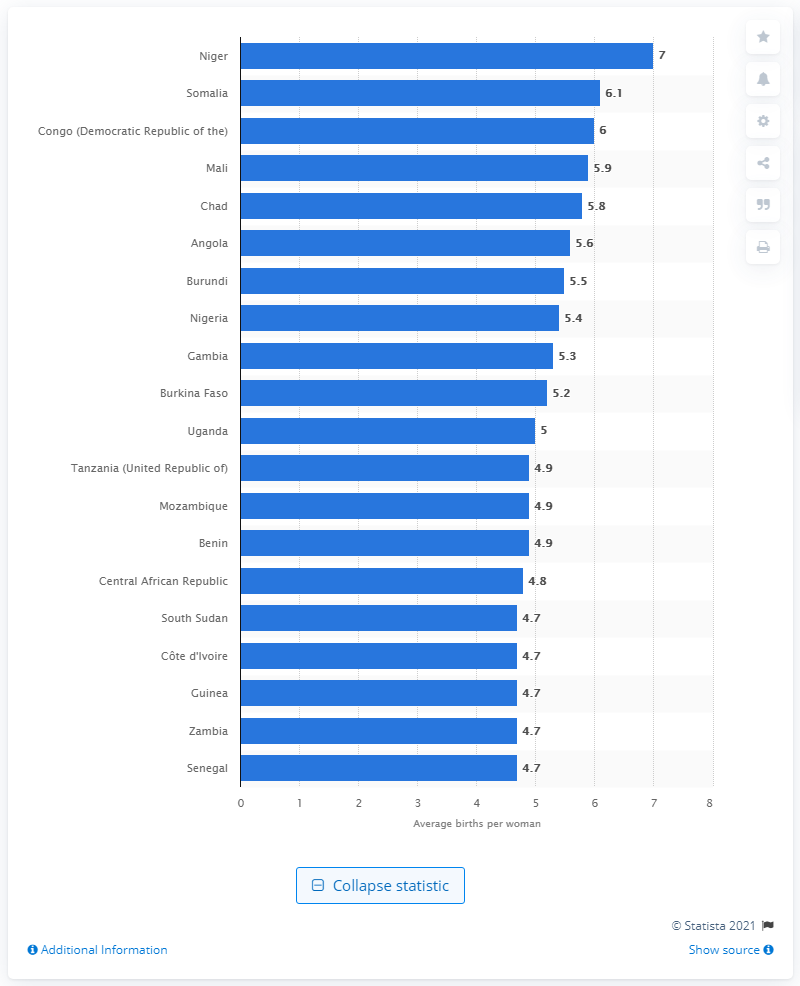Give some essential details in this illustration. Niger had the highest average birth rate per woman in the world in 2021. Between 2015 and 2020, Somalia's birth rate was 6.1. 